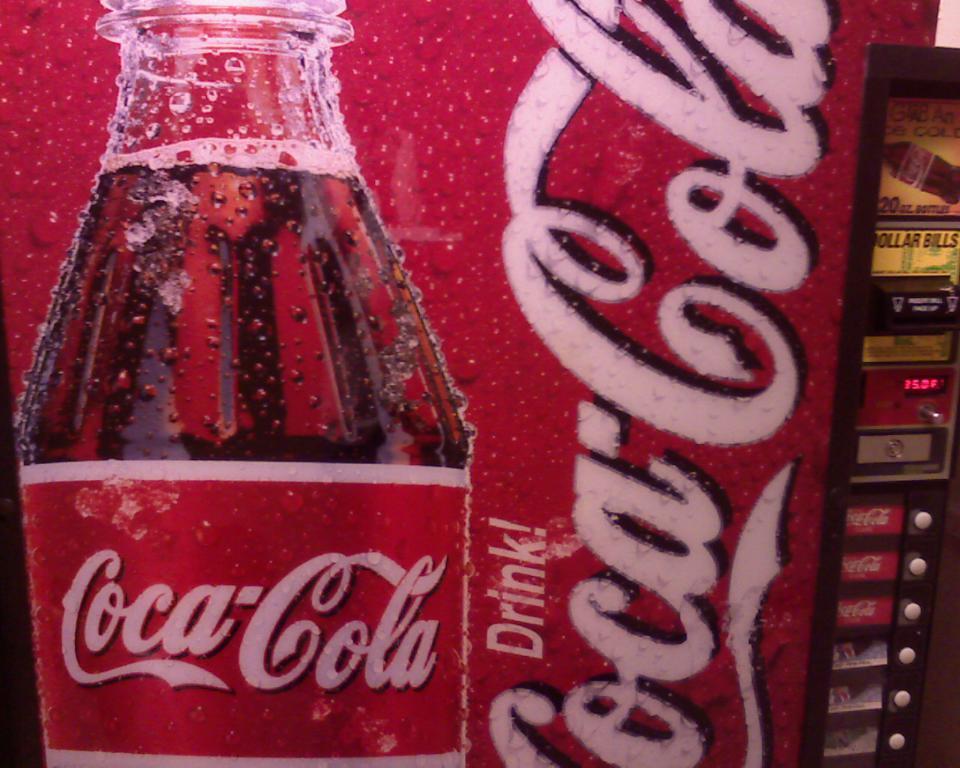Describe this image in one or two sentences. This picture seems to be of inside. In the center there is a banner on which the picture of a bottle containing drink and a text is printed. On the right there are some buttons and a screen displaying numbers. 